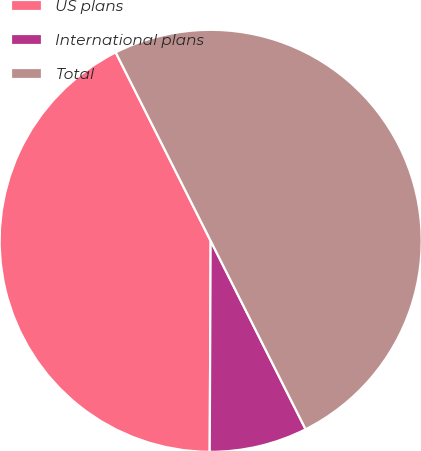<chart> <loc_0><loc_0><loc_500><loc_500><pie_chart><fcel>US plans<fcel>International plans<fcel>Total<nl><fcel>42.5%<fcel>7.5%<fcel>50.0%<nl></chart> 